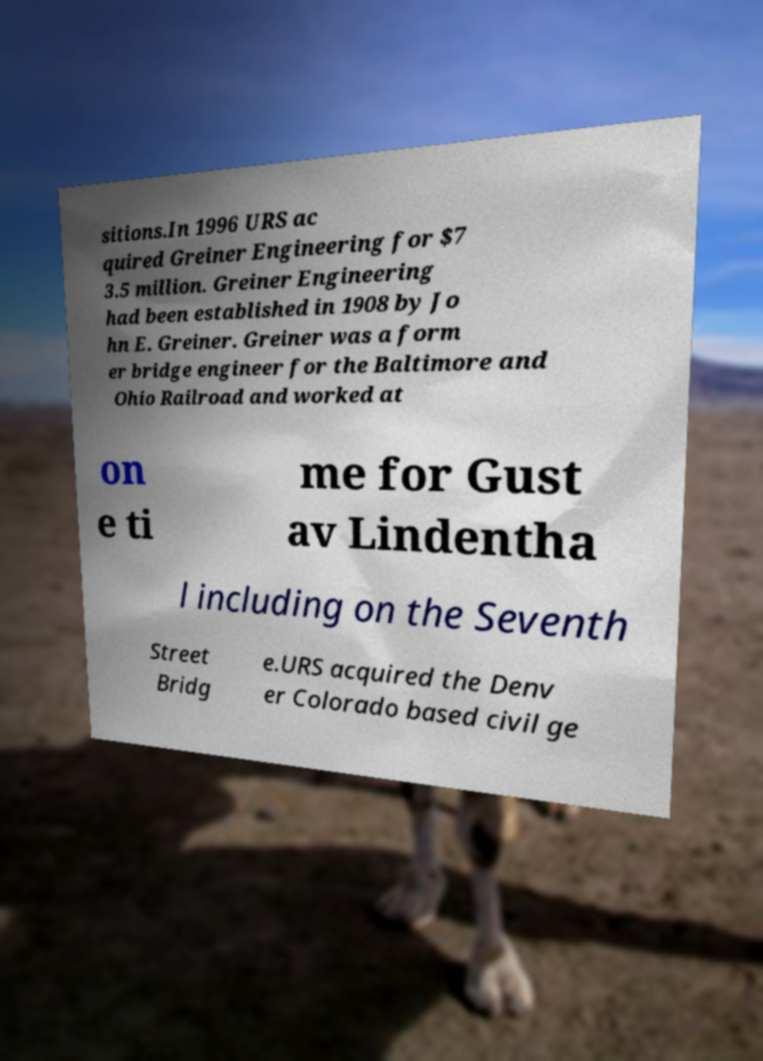Please identify and transcribe the text found in this image. sitions.In 1996 URS ac quired Greiner Engineering for $7 3.5 million. Greiner Engineering had been established in 1908 by Jo hn E. Greiner. Greiner was a form er bridge engineer for the Baltimore and Ohio Railroad and worked at on e ti me for Gust av Lindentha l including on the Seventh Street Bridg e.URS acquired the Denv er Colorado based civil ge 